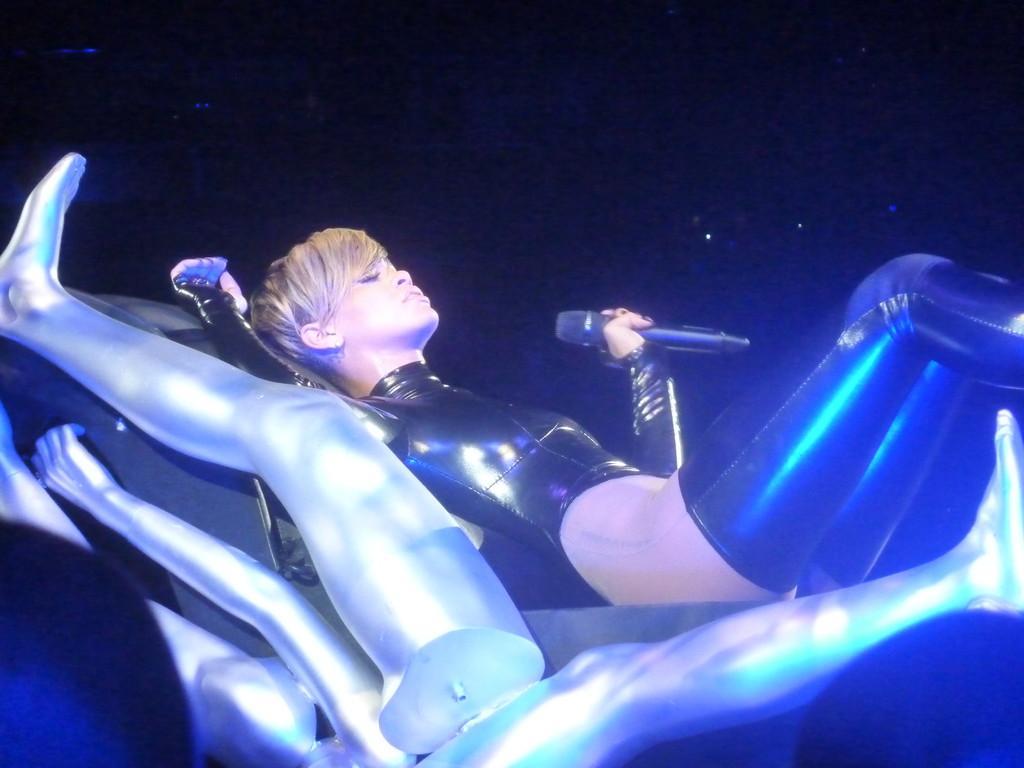How would you summarize this image in a sentence or two? In this image we can see a person lying on a surface and holding a mic, beside the person there are some silver colored objects which looks like human hands and legs. 